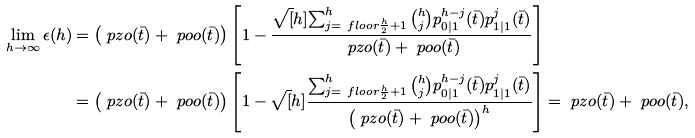Convert formula to latex. <formula><loc_0><loc_0><loc_500><loc_500>\lim _ { h \to \infty } \epsilon ( h ) & = \left ( \ p z o ( \bar { t } ) + \ p o o ( \bar { t } ) \right ) \left [ 1 - \frac { \sqrt { [ } h ] { \sum _ { j = \ f l o o r { \frac { h } { 2 } } + 1 } ^ { h } { h \choose j } p ^ { h - j } _ { 0 | 1 } ( \bar { t } ) p ^ { j } _ { 1 | 1 } ( \bar { t } ) } } { \ p z o ( \bar { t } ) + \ p o o ( \bar { t } ) } \right ] \\ & = \left ( \ p z o ( \bar { t } ) + \ p o o ( \bar { t } ) \right ) \left [ 1 - \sqrt { [ } h ] { \frac { \sum _ { j = \ f l o o r { \frac { h } { 2 } } + 1 } ^ { h } { h \choose j } p ^ { h - j } _ { 0 | 1 } ( \bar { t } ) p ^ { j } _ { 1 | 1 } ( \bar { t } ) } { \left ( \ p z o ( \bar { t } ) + \ p o o ( \bar { t } ) \right ) ^ { h } } } \right ] = \ p z o ( \bar { t } ) + \ p o o ( \bar { t } ) ,</formula> 